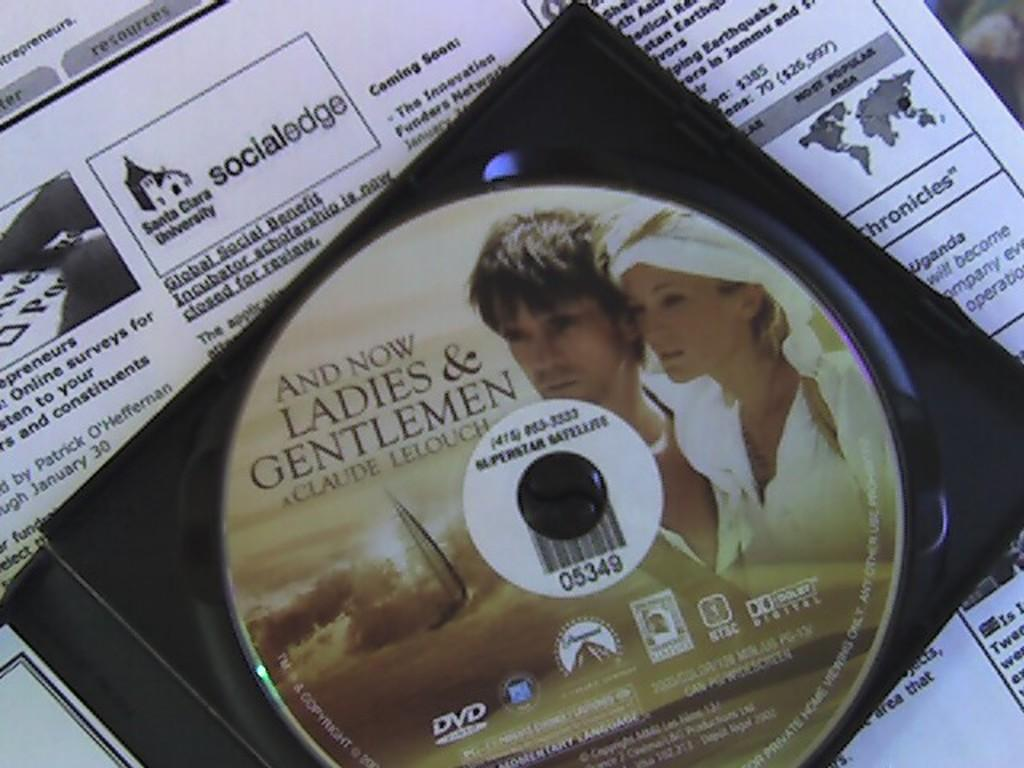What is the main object in the image? There is a CD in the image. How is the CD positioned in the image? The CD is on a paper. What type of voice can be heard coming from the CD in the image? There is no indication in the image that the CD is playing any audio, so it's not possible to determine what, if any, voice might be heard. 